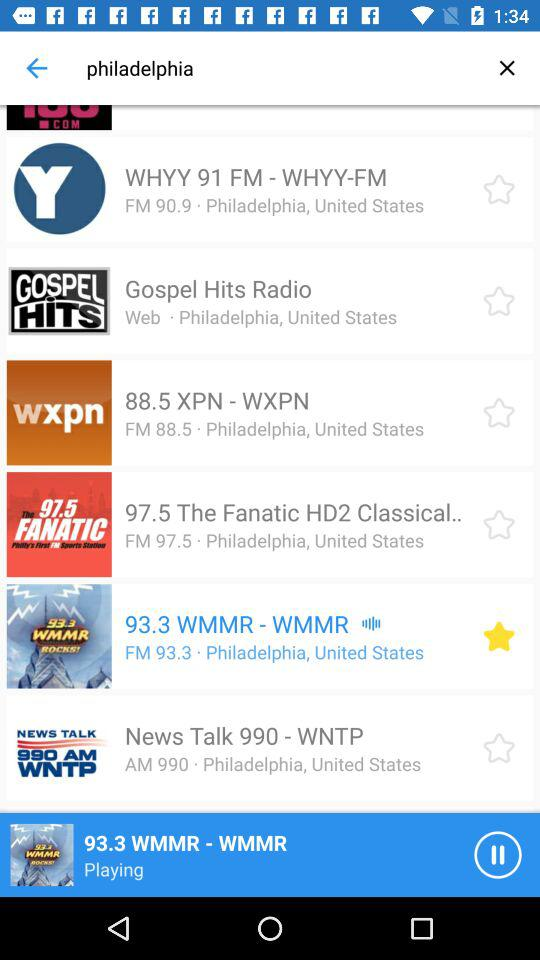Which radio station is playing? The radio station playing is "WMMR". 